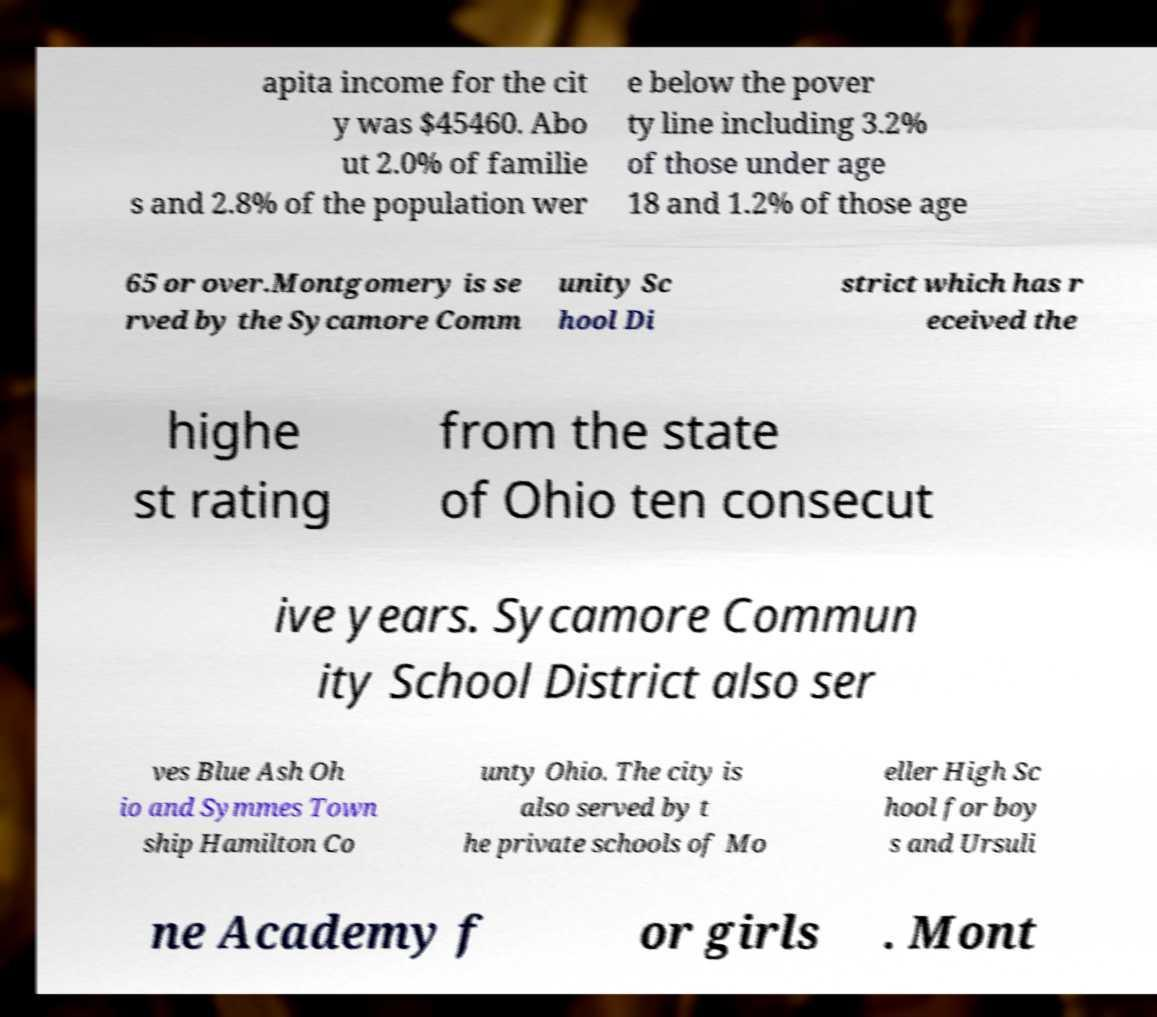Can you read and provide the text displayed in the image?This photo seems to have some interesting text. Can you extract and type it out for me? apita income for the cit y was $45460. Abo ut 2.0% of familie s and 2.8% of the population wer e below the pover ty line including 3.2% of those under age 18 and 1.2% of those age 65 or over.Montgomery is se rved by the Sycamore Comm unity Sc hool Di strict which has r eceived the highe st rating from the state of Ohio ten consecut ive years. Sycamore Commun ity School District also ser ves Blue Ash Oh io and Symmes Town ship Hamilton Co unty Ohio. The city is also served by t he private schools of Mo eller High Sc hool for boy s and Ursuli ne Academy f or girls . Mont 